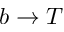<formula> <loc_0><loc_0><loc_500><loc_500>b \to T</formula> 